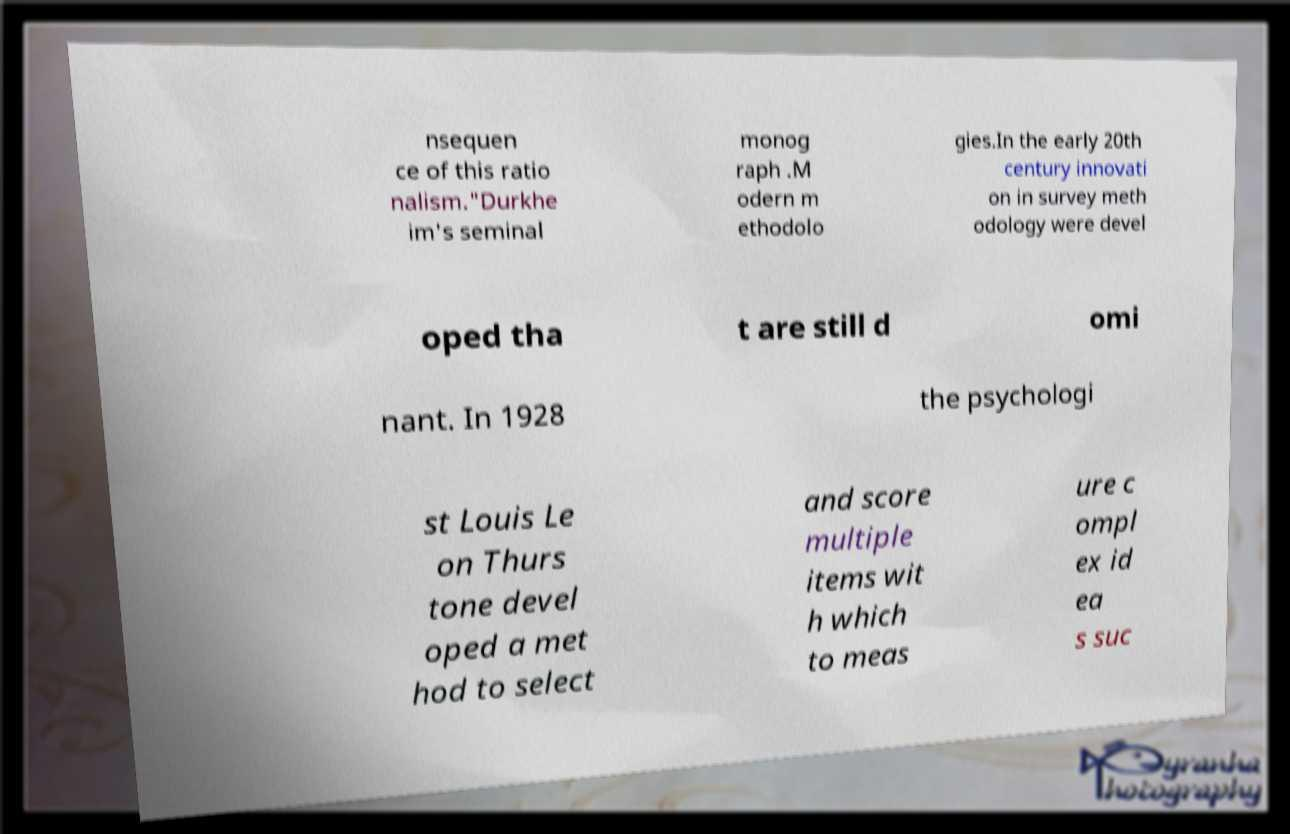Could you assist in decoding the text presented in this image and type it out clearly? nsequen ce of this ratio nalism."Durkhe im's seminal monog raph .M odern m ethodolo gies.In the early 20th century innovati on in survey meth odology were devel oped tha t are still d omi nant. In 1928 the psychologi st Louis Le on Thurs tone devel oped a met hod to select and score multiple items wit h which to meas ure c ompl ex id ea s suc 